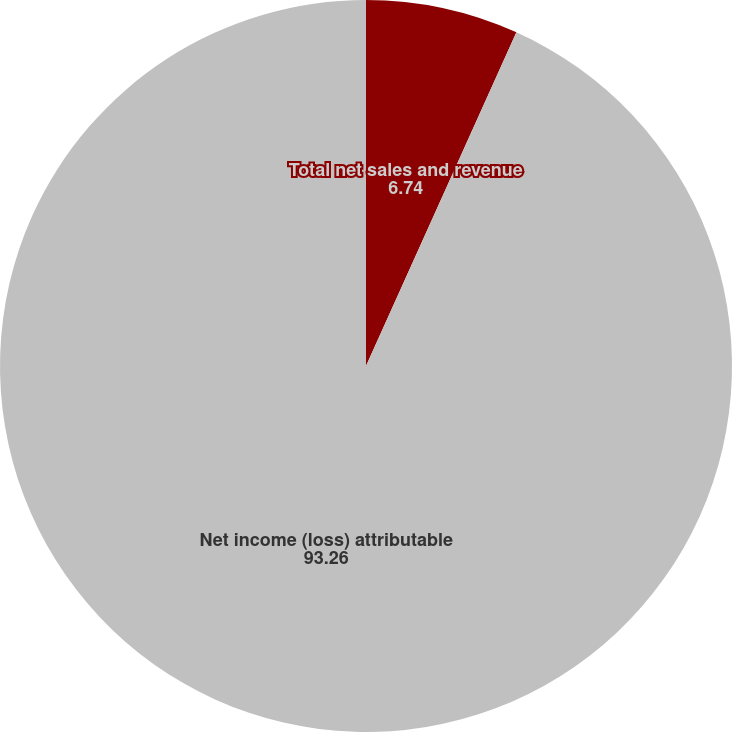Convert chart. <chart><loc_0><loc_0><loc_500><loc_500><pie_chart><fcel>Total net sales and revenue<fcel>Net income (loss) attributable<nl><fcel>6.74%<fcel>93.26%<nl></chart> 